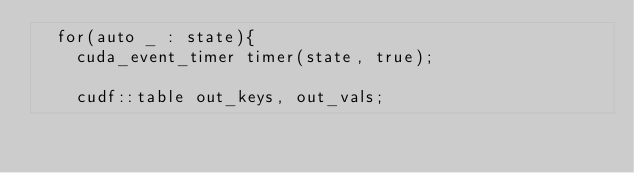Convert code to text. <code><loc_0><loc_0><loc_500><loc_500><_Cuda_>  for(auto _ : state){
    cuda_event_timer timer(state, true);

    cudf::table out_keys, out_vals;</code> 